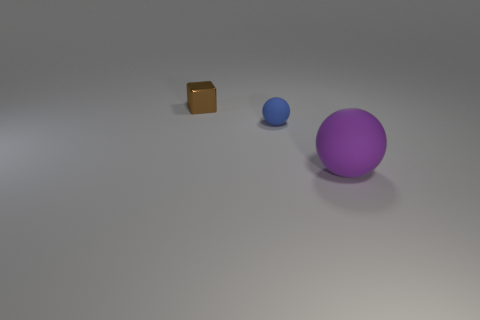Add 1 tiny blue matte objects. How many objects exist? 4 Subtract all balls. How many objects are left? 1 Subtract 0 gray cylinders. How many objects are left? 3 Subtract all blue objects. Subtract all big red metal cubes. How many objects are left? 2 Add 1 big objects. How many big objects are left? 2 Add 1 metallic things. How many metallic things exist? 2 